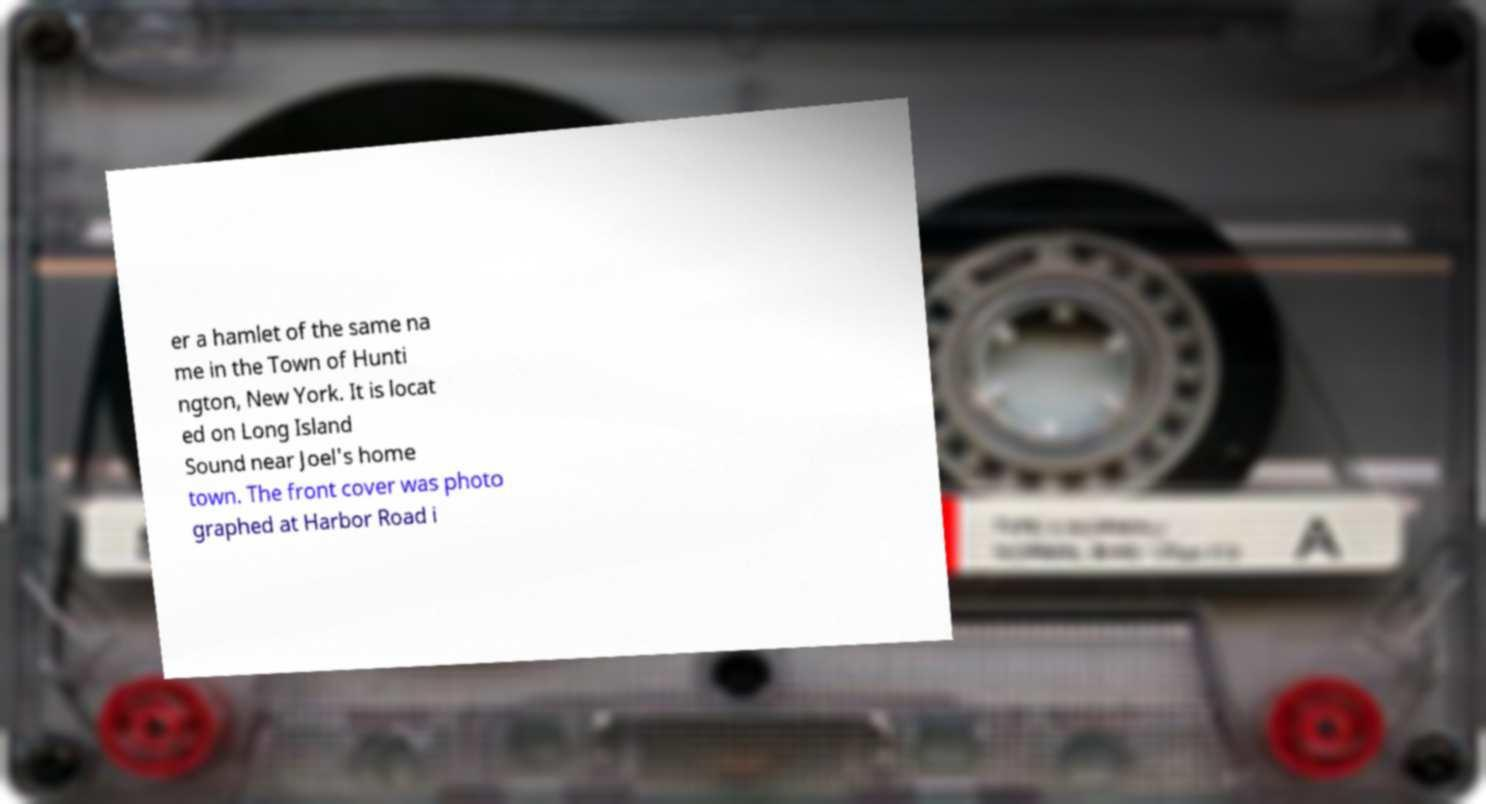Can you read and provide the text displayed in the image?This photo seems to have some interesting text. Can you extract and type it out for me? er a hamlet of the same na me in the Town of Hunti ngton, New York. It is locat ed on Long Island Sound near Joel's home town. The front cover was photo graphed at Harbor Road i 